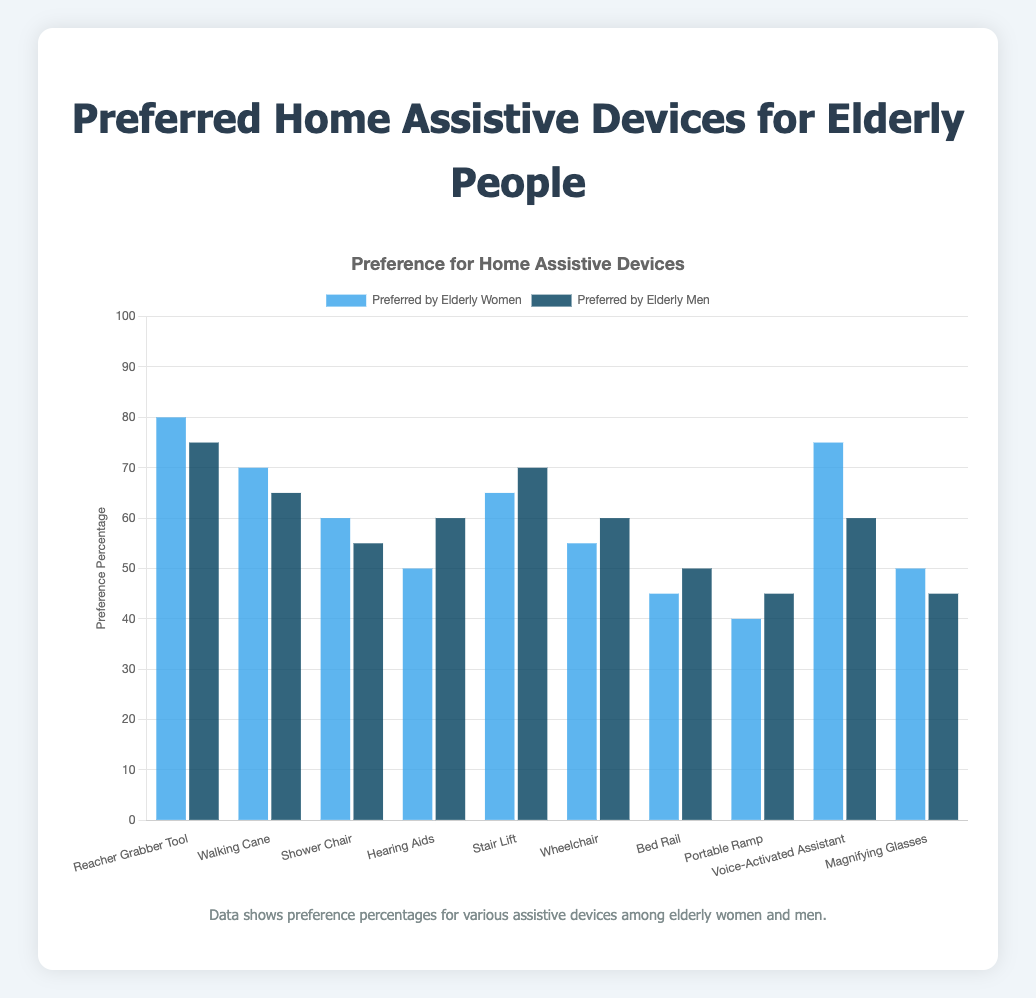Which assistive device is preferred by elderly women the most? Look at the bar heights for elderly women's preferences. The "Reacher Grabber Tool" has the highest value at 80%.
Answer: Reacher Grabber Tool Which assistive device is least preferred by elderly men? Look at the bar heights for elderly men's preferences. The "Magnifying Glasses" has the smallest value at 45%.
Answer: Magnifying Glasses What is the difference in preference for the Voice-Activated Assistant between elderly women and men? Compare the bar heights for the "Voice-Activated Assistant." Elderly women prefer it 75%, and elderly men prefer it 60%. Subtract 60 from 75.
Answer: 15% Among the listed devices, which one has an equal preference by both elderly men and women? Look for bars of equal height in both categories. The "Portable Ramp" is preferred equally at 45% by both men and women.
Answer: Portable Ramp Which device shows a higher preference in elderly men compared to women by a large margin? Compare bar heights for all devices to find significant differences. Hearing Aids' preference is 60% for men and 50% for women, showing a 10% difference.
Answer: Hearing Aids What is the combined preference percentage for the Reacher Grabber Tool and Walking Cane by elderly women? Add the preference percentages for Reacher Grabber Tool (80) and Walking Cane (70).
Answer: 150% What is the average preference percentage for wheelchairs across both elderly men and women? Find the values for both men (60%) and women (55%). Add these together and divide by 2.
Answer: 57.5% Which color bars represent the preferences of elderly women in the chart? Identify the color associated with the "Preferred by Elderly Women" label in the chart legend.
Answer: Blue What is the total preference percentage for the Stair Lift across both elderly men and women? Add the preference percentages for the Stair Lift (70) for men and (65) for women.
Answer: 135% What is the median preference percentage for elderly men across all devices? List preference percentages for elderly men: 75, 65, 55, 60, 70, 60, 50, 45, 60, 45. The sorted list is 45, 45, 50, 55, 60, 60, 60, 65, 70, 75. The median is the middle value in the sorted list (60).
Answer: 60% 